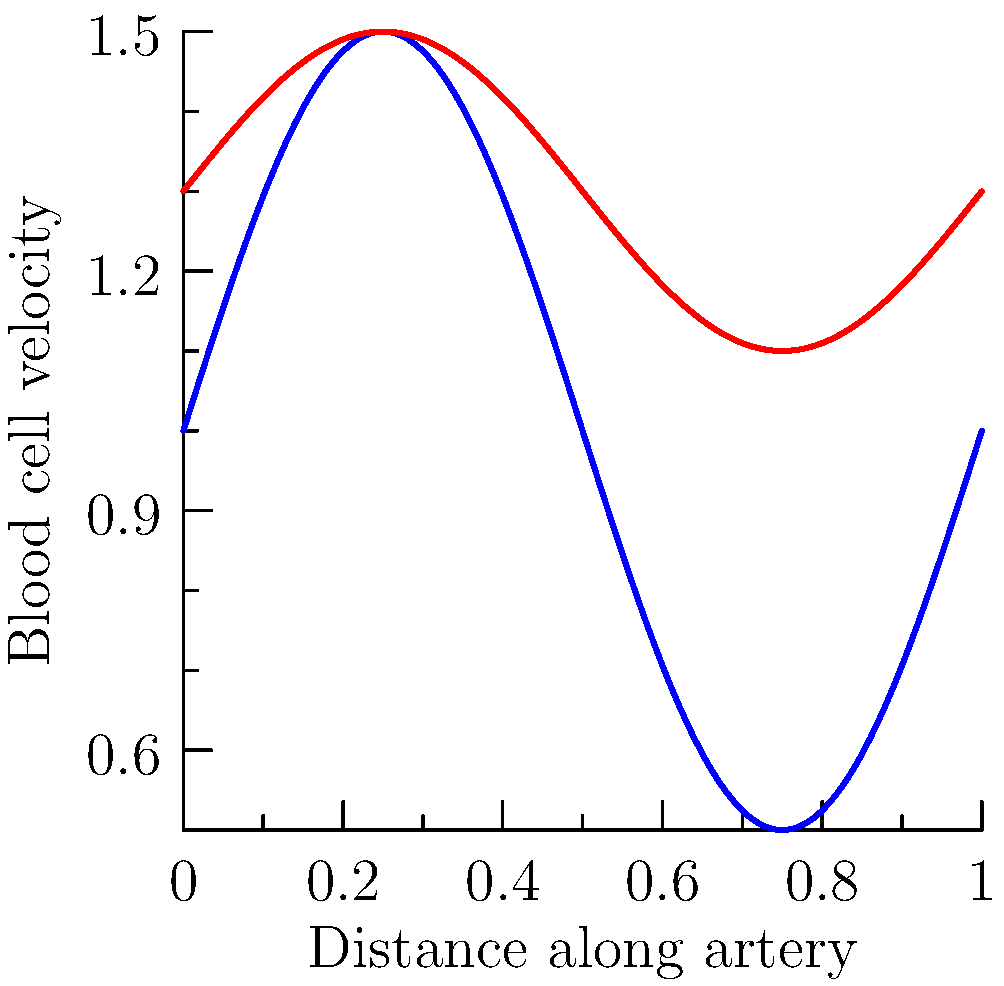Based on the graph showing blood cell velocity before and after stent placement, what can be concluded about the effect of the stent on blood flow in the artery? To analyze the effect of the stent on blood flow, we need to compare the velocity profiles before and after stent placement:

1. Before stent placement (blue line):
   - The velocity profile shows larger oscillations.
   - The average velocity is lower, centered around 1 unit.
   - The peak velocities are lower.

2. After stent placement (red line):
   - The velocity profile shows smaller oscillations.
   - The average velocity is higher, centered around 1.3 units.
   - The peak velocities are higher.

3. Interpreting the changes:
   - Reduced oscillations indicate smoother blood flow.
   - Higher average velocity suggests improved overall blood flow.
   - Higher peak velocities indicate better maximum flow rates.

4. Clinical significance:
   - Smoother, faster blood flow reduces the risk of clot formation.
   - Improved blood flow means better oxygen and nutrient delivery to tissues.
   - Higher velocities can help maintain the patency of the artery.

Therefore, the stent has effectively improved blood flow in the artery by increasing velocity and reducing turbulence.
Answer: The stent improved blood flow by increasing average velocity and reducing flow oscillations. 